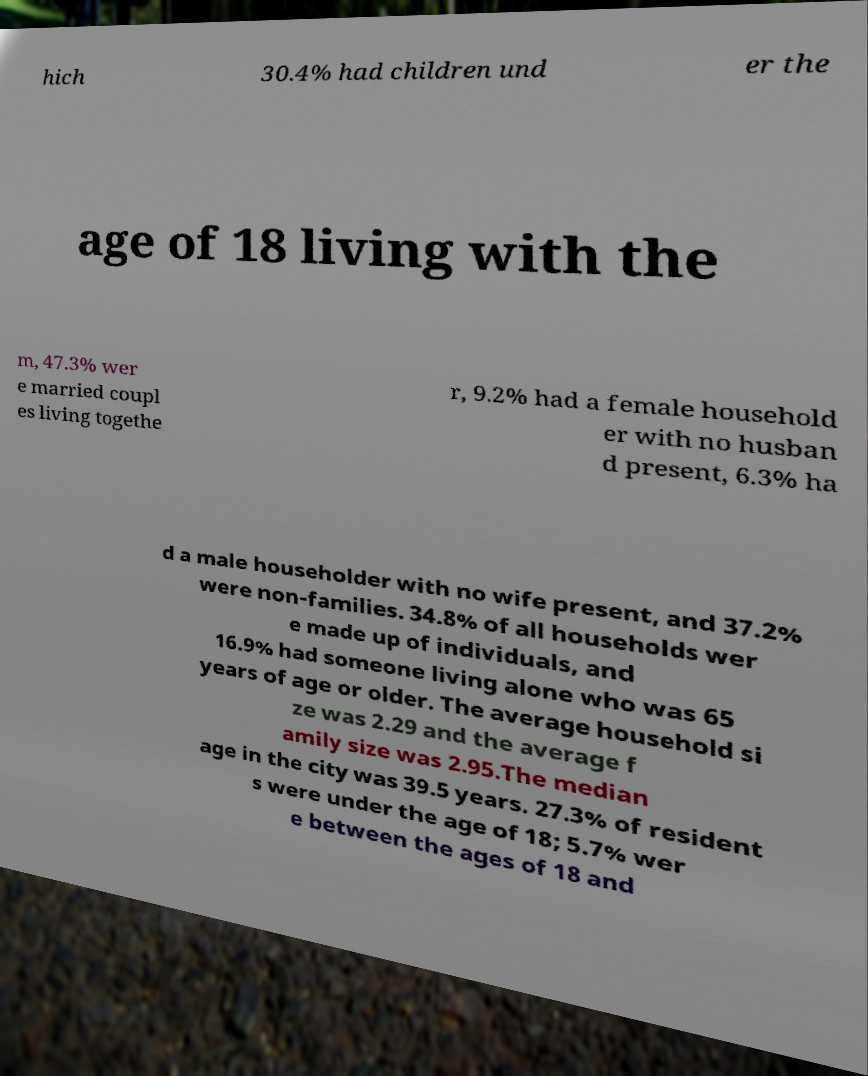Can you read and provide the text displayed in the image?This photo seems to have some interesting text. Can you extract and type it out for me? hich 30.4% had children und er the age of 18 living with the m, 47.3% wer e married coupl es living togethe r, 9.2% had a female household er with no husban d present, 6.3% ha d a male householder with no wife present, and 37.2% were non-families. 34.8% of all households wer e made up of individuals, and 16.9% had someone living alone who was 65 years of age or older. The average household si ze was 2.29 and the average f amily size was 2.95.The median age in the city was 39.5 years. 27.3% of resident s were under the age of 18; 5.7% wer e between the ages of 18 and 